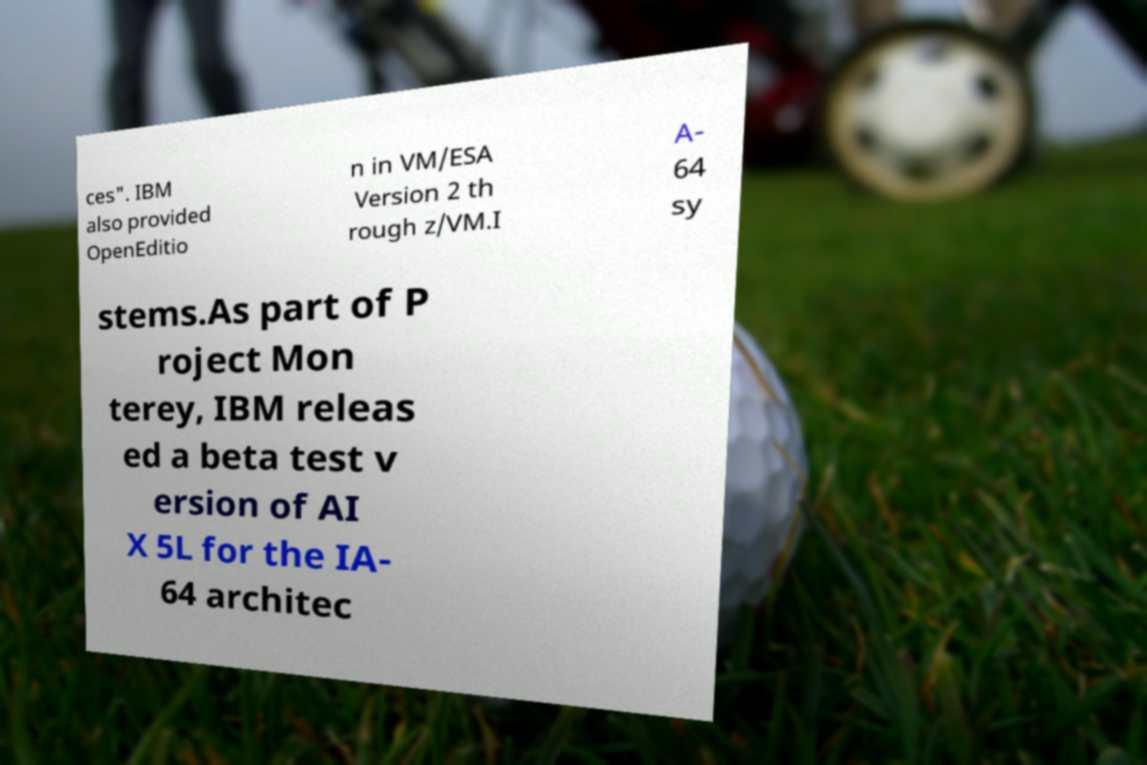There's text embedded in this image that I need extracted. Can you transcribe it verbatim? ces". IBM also provided OpenEditio n in VM/ESA Version 2 th rough z/VM.I A- 64 sy stems.As part of P roject Mon terey, IBM releas ed a beta test v ersion of AI X 5L for the IA- 64 architec 